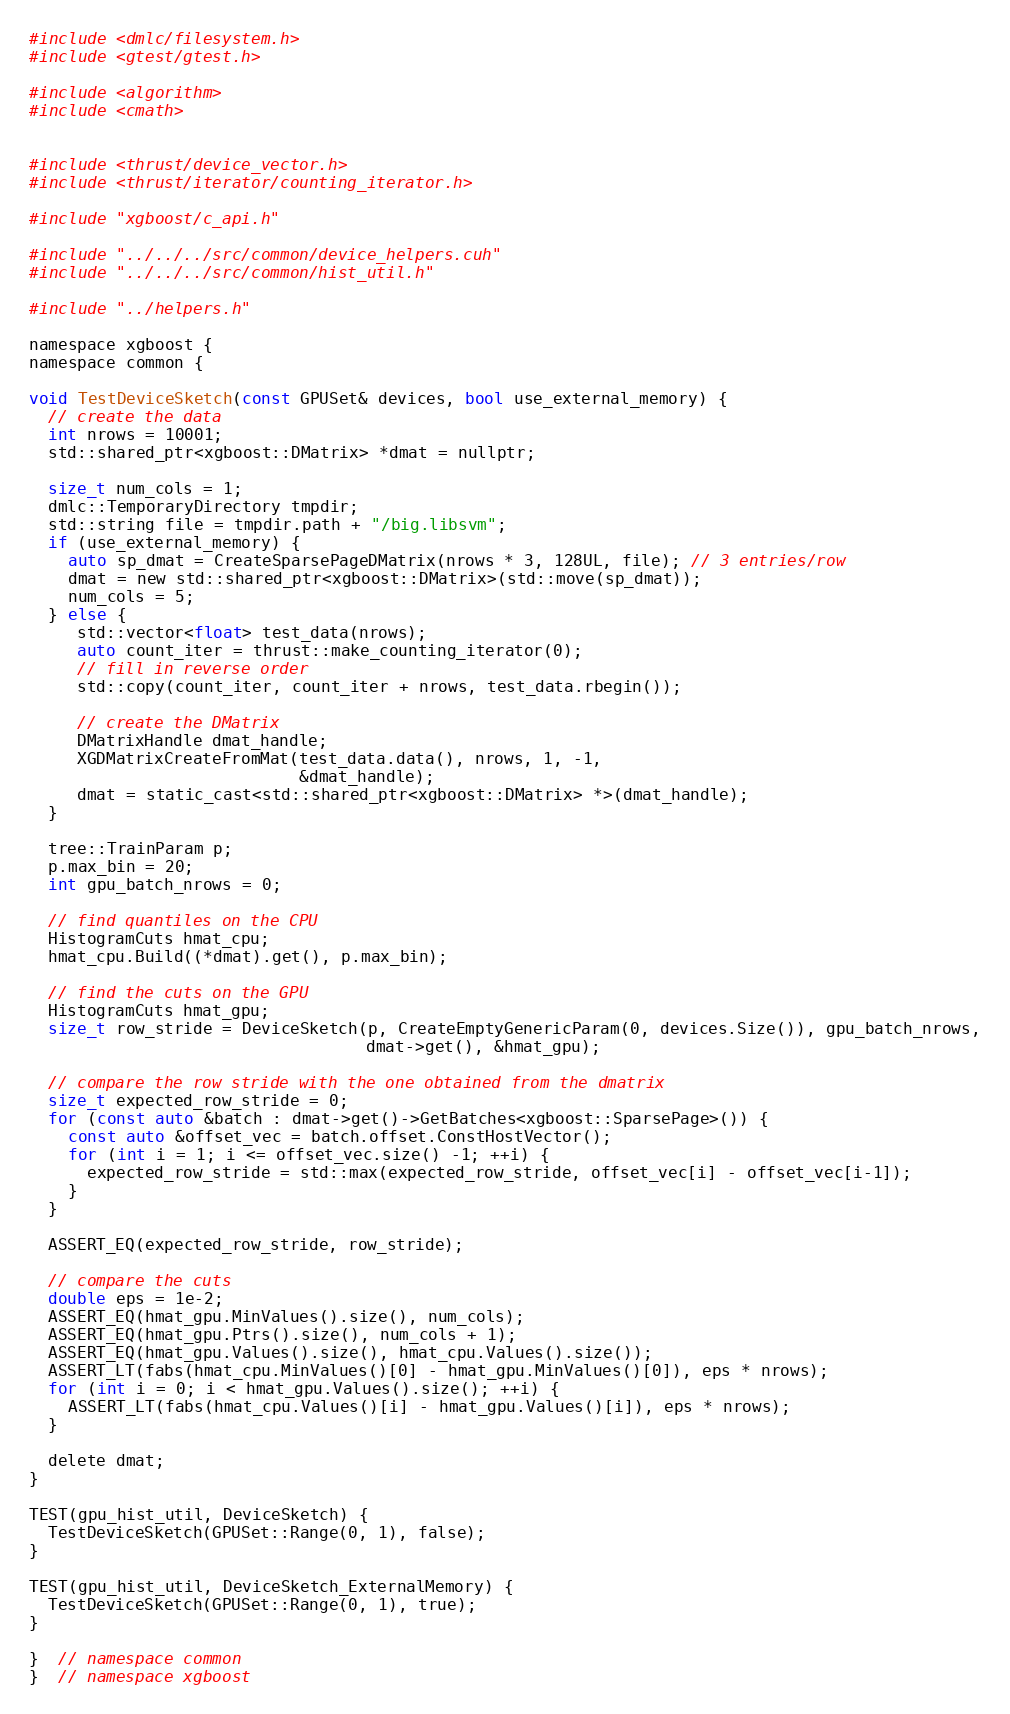Convert code to text. <code><loc_0><loc_0><loc_500><loc_500><_Cuda_>#include <dmlc/filesystem.h>
#include <gtest/gtest.h>

#include <algorithm>
#include <cmath>


#include <thrust/device_vector.h>
#include <thrust/iterator/counting_iterator.h>

#include "xgboost/c_api.h"

#include "../../../src/common/device_helpers.cuh"
#include "../../../src/common/hist_util.h"

#include "../helpers.h"

namespace xgboost {
namespace common {

void TestDeviceSketch(const GPUSet& devices, bool use_external_memory) {
  // create the data
  int nrows = 10001;
  std::shared_ptr<xgboost::DMatrix> *dmat = nullptr;

  size_t num_cols = 1;
  dmlc::TemporaryDirectory tmpdir;
  std::string file = tmpdir.path + "/big.libsvm";
  if (use_external_memory) {
    auto sp_dmat = CreateSparsePageDMatrix(nrows * 3, 128UL, file); // 3 entries/row
    dmat = new std::shared_ptr<xgboost::DMatrix>(std::move(sp_dmat));
    num_cols = 5;
  } else {
     std::vector<float> test_data(nrows);
     auto count_iter = thrust::make_counting_iterator(0);
     // fill in reverse order
     std::copy(count_iter, count_iter + nrows, test_data.rbegin());

     // create the DMatrix
     DMatrixHandle dmat_handle;
     XGDMatrixCreateFromMat(test_data.data(), nrows, 1, -1,
                            &dmat_handle);
     dmat = static_cast<std::shared_ptr<xgboost::DMatrix> *>(dmat_handle);
  }

  tree::TrainParam p;
  p.max_bin = 20;
  int gpu_batch_nrows = 0;

  // find quantiles on the CPU
  HistogramCuts hmat_cpu;
  hmat_cpu.Build((*dmat).get(), p.max_bin);

  // find the cuts on the GPU
  HistogramCuts hmat_gpu;
  size_t row_stride = DeviceSketch(p, CreateEmptyGenericParam(0, devices.Size()), gpu_batch_nrows,
                                   dmat->get(), &hmat_gpu);

  // compare the row stride with the one obtained from the dmatrix
  size_t expected_row_stride = 0;
  for (const auto &batch : dmat->get()->GetBatches<xgboost::SparsePage>()) {
    const auto &offset_vec = batch.offset.ConstHostVector();
    for (int i = 1; i <= offset_vec.size() -1; ++i) {
      expected_row_stride = std::max(expected_row_stride, offset_vec[i] - offset_vec[i-1]);
    }
  }

  ASSERT_EQ(expected_row_stride, row_stride);

  // compare the cuts
  double eps = 1e-2;
  ASSERT_EQ(hmat_gpu.MinValues().size(), num_cols);
  ASSERT_EQ(hmat_gpu.Ptrs().size(), num_cols + 1);
  ASSERT_EQ(hmat_gpu.Values().size(), hmat_cpu.Values().size());
  ASSERT_LT(fabs(hmat_cpu.MinValues()[0] - hmat_gpu.MinValues()[0]), eps * nrows);
  for (int i = 0; i < hmat_gpu.Values().size(); ++i) {
    ASSERT_LT(fabs(hmat_cpu.Values()[i] - hmat_gpu.Values()[i]), eps * nrows);
  }

  delete dmat;
}

TEST(gpu_hist_util, DeviceSketch) {
  TestDeviceSketch(GPUSet::Range(0, 1), false);
}

TEST(gpu_hist_util, DeviceSketch_ExternalMemory) {
  TestDeviceSketch(GPUSet::Range(0, 1), true);
}

}  // namespace common
}  // namespace xgboost
</code> 